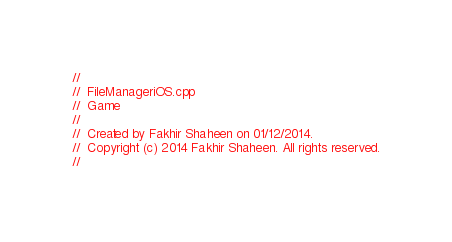Convert code to text. <code><loc_0><loc_0><loc_500><loc_500><_ObjectiveC_>//
//  FileManageriOS.cpp
//  Game
//
//  Created by Fakhir Shaheen on 01/12/2014.
//  Copyright (c) 2014 Fakhir Shaheen. All rights reserved.
//
</code> 